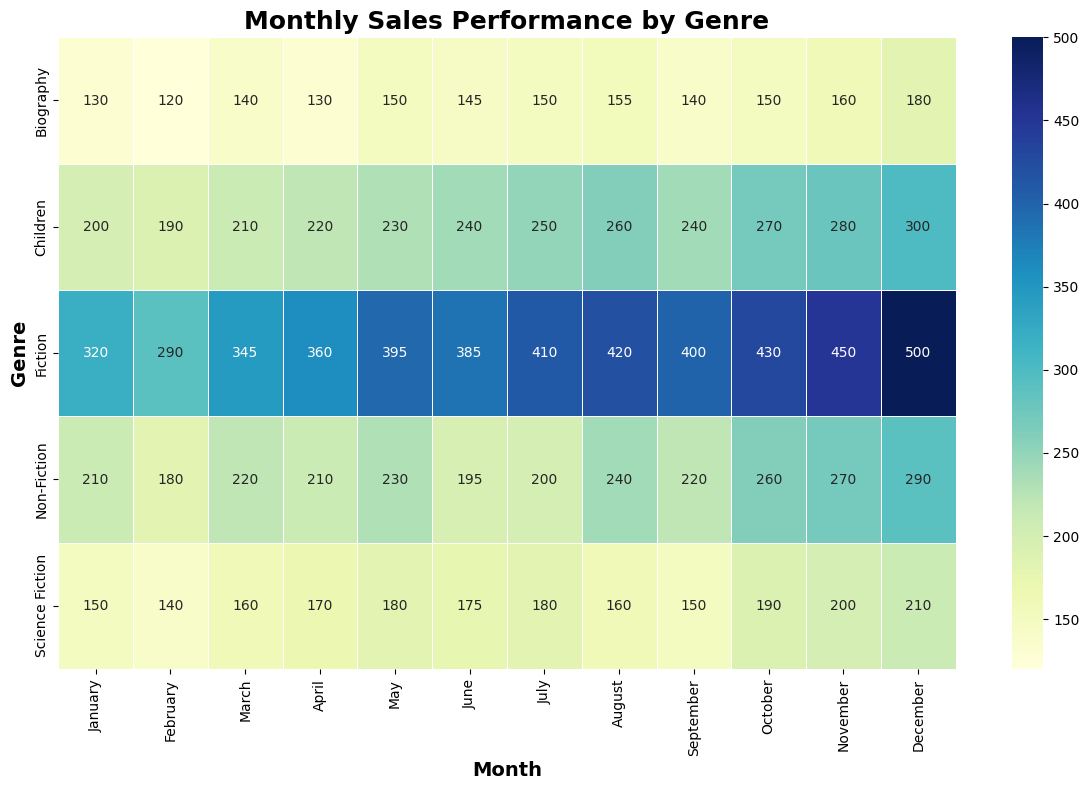Which genre has the highest sales in December? The heatmap shows the sales values for each genre and month. By looking at December for each genre, Fiction has the highest sales value with 500.
Answer: Fiction Which month shows the lowest sales for Science Fiction? By scanning the heatmap for Science Fiction, February has the lowest sales value of 140.
Answer: February What's the total sales for Fiction in the first quarter (January, February, March)? Add up the sales for Fiction in January (320), February (290), and March (345). The total is 320 + 290 + 345 = 955.
Answer: 955 Compare the sales of Children’s books in June and August. Is there an increase or a decrease? June has 240 sales, and August has 260 sales. Comparing these, there is an increase of 20.
Answer: Increase Which genre shows the most consistent sales throughout the year? By looking at the heatmap, Children’s books show relatively consistent sales with values gradually increasing every month without significant dips.
Answer: Children What is the difference in sales between Non-Fiction and Biography in November? November sales for Non-Fiction are 270, and for Biography, it's 160. Difference is 270 - 160 = 110.
Answer: 110 Which genre has the largest increase in sales from January to December? The heatmap shows the change in sales. Fiction increases from 320 in January to 500 in December, an increase of 180, which is the largest among the genres.
Answer: Fiction How do Children’s book sales in May compare to Science Fiction sales in October? Children's book sales in May are 230, and Science Fiction sales in October are 190. Children's books have higher sales.
Answer: Children's books What’s the average sales for Non-Fiction genre across the months? Sum the sales for Non-Fiction from January to December and divide by 12. The total is 210 + 180 + 220 + 210 + 230 + 195 + 200 + 240 + 220 + 260 + 270 + 290 = 2925. The average is 2925 / 12 = 243.75.
Answer: 243.75 Which genres have sales above 400 in any month? By checking the heatmap, only Fiction has sales above 400 (from July to December).
Answer: Fiction 